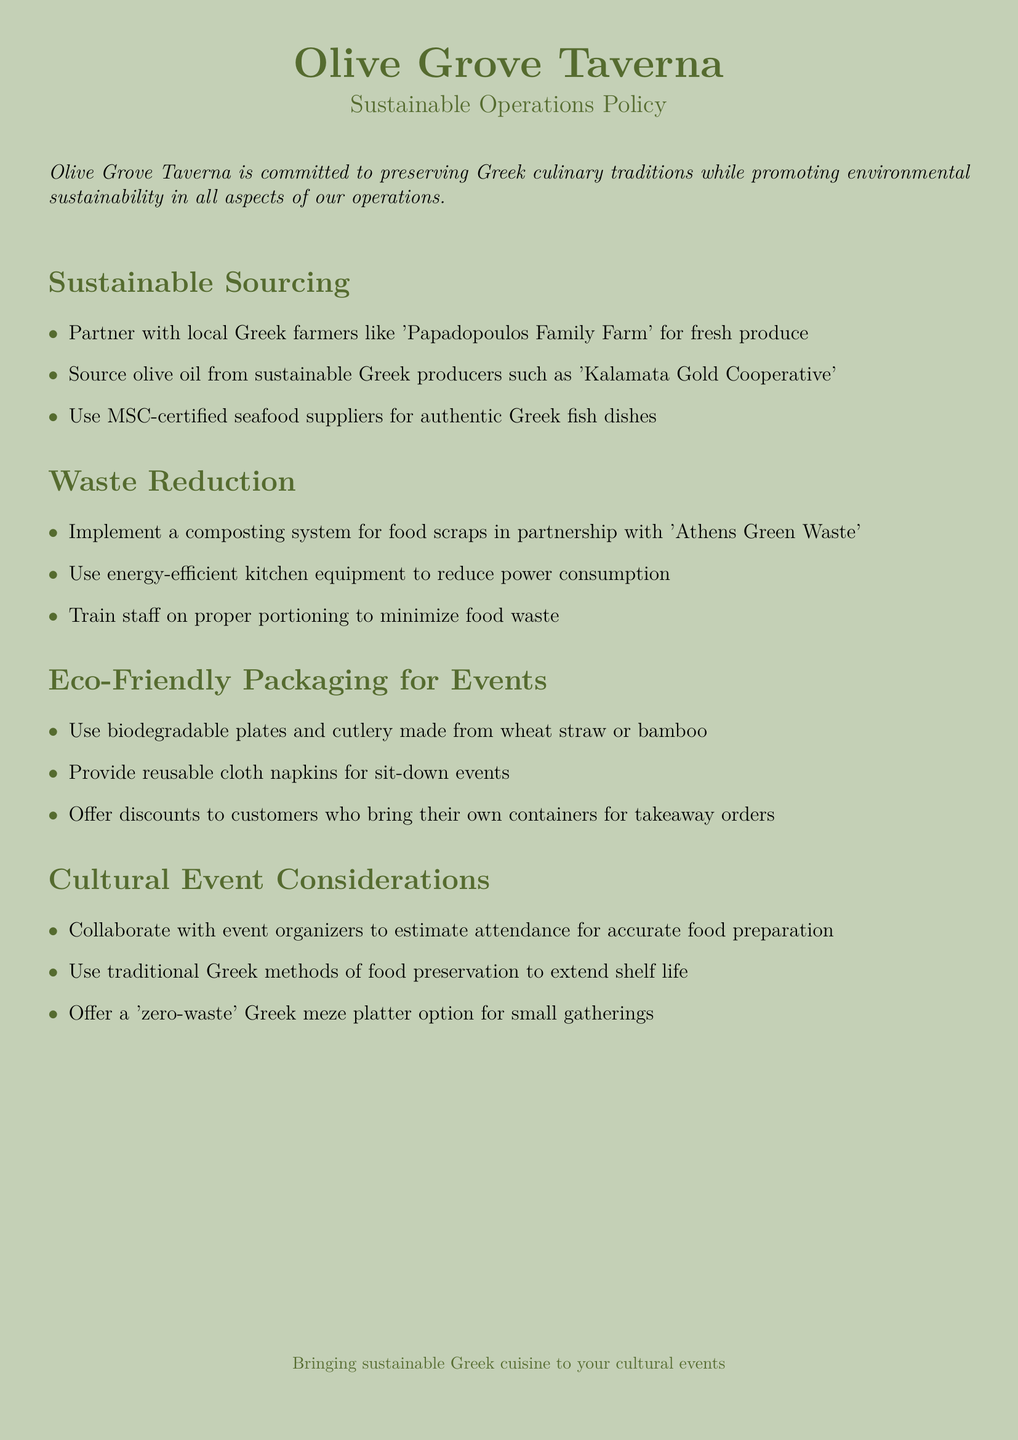What is the name of the taverna? The name of the taverna is mentioned in the header of the document.
Answer: Olive Grove Taverna Who do we partner with for fresh produce? The document specifies a specific local farmer that Olive Grove Taverna partners with for fresh produce.
Answer: Papadopoulos Family Farm What type of seafood suppliers do we use? The document indicates a certification type that is used for seafood suppliers.
Answer: MSC-certified What type of kitchen equipment is mentioned for waste reduction? The document refers to the category of kitchen equipment aimed at increasing efficiency and reducing waste.
Answer: Energy-efficient What type of napkins are provided for sit-down events? The type of napkins specified for use during sit-down events is described in the eco-friendly packaging section.
Answer: Reusable cloth What discount is offered for takeaway orders? The document mentions a specific action that customers can take to receive a discount on takeaway orders.
Answer: Bring their own containers What is one of the cultural event considerations? The document lists factors to consider when preparing for cultural events involving food.
Answer: Estimate attendance Which cooperative provides our olive oil? The document lists a specific cooperative known for sustainably producing olive oil.
Answer: Kalamata Gold Cooperative 